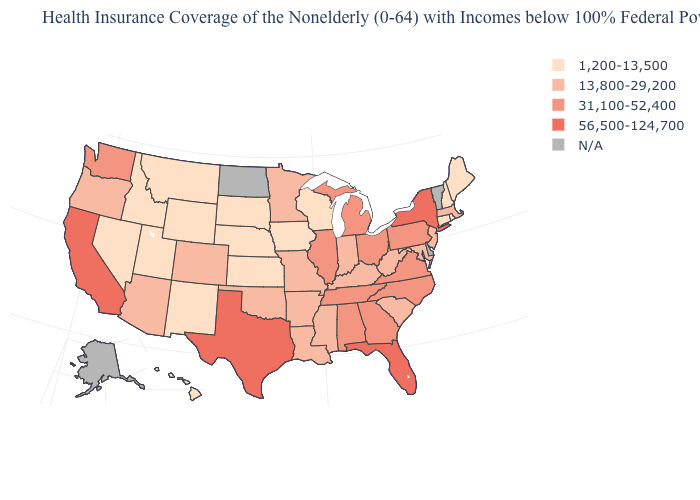Among the states that border Oregon , does California have the lowest value?
Answer briefly. No. What is the lowest value in the USA?
Keep it brief. 1,200-13,500. Does the map have missing data?
Write a very short answer. Yes. Does the first symbol in the legend represent the smallest category?
Keep it brief. Yes. Name the states that have a value in the range 13,800-29,200?
Quick response, please. Arizona, Arkansas, Colorado, Indiana, Kentucky, Louisiana, Maryland, Massachusetts, Minnesota, Mississippi, Missouri, New Jersey, Oklahoma, Oregon, South Carolina, West Virginia. What is the highest value in states that border Vermont?
Short answer required. 56,500-124,700. What is the value of Missouri?
Give a very brief answer. 13,800-29,200. What is the value of Missouri?
Short answer required. 13,800-29,200. Name the states that have a value in the range 56,500-124,700?
Keep it brief. California, Florida, New York, Texas. Which states have the lowest value in the West?
Concise answer only. Hawaii, Idaho, Montana, Nevada, New Mexico, Utah, Wyoming. Does the map have missing data?
Concise answer only. Yes. Among the states that border California , does Oregon have the highest value?
Give a very brief answer. Yes. Among the states that border New Hampshire , which have the highest value?
Be succinct. Massachusetts. What is the value of Missouri?
Be succinct. 13,800-29,200. 